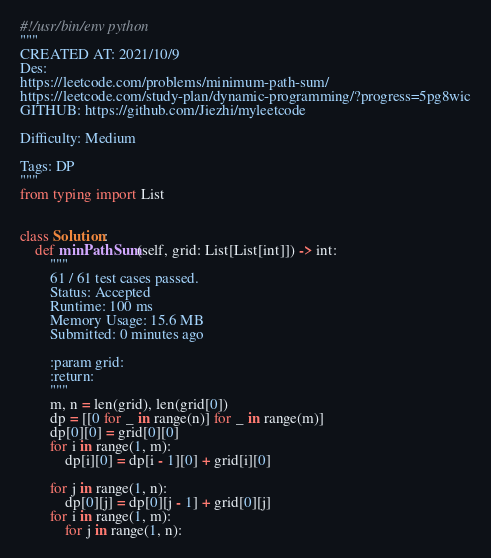<code> <loc_0><loc_0><loc_500><loc_500><_Python_>#!/usr/bin/env python
"""
CREATED AT: 2021/10/9
Des:
https://leetcode.com/problems/minimum-path-sum/
https://leetcode.com/study-plan/dynamic-programming/?progress=5pg8wic
GITHUB: https://github.com/Jiezhi/myleetcode

Difficulty: Medium

Tags: DP
"""
from typing import List


class Solution:
    def minPathSum(self, grid: List[List[int]]) -> int:
        """
        61 / 61 test cases passed.
        Status: Accepted
        Runtime: 100 ms
        Memory Usage: 15.6 MB
        Submitted: 0 minutes ago

        :param grid:
        :return:
        """
        m, n = len(grid), len(grid[0])
        dp = [[0 for _ in range(n)] for _ in range(m)]
        dp[0][0] = grid[0][0]
        for i in range(1, m):
            dp[i][0] = dp[i - 1][0] + grid[i][0]

        for j in range(1, n):
            dp[0][j] = dp[0][j - 1] + grid[0][j]
        for i in range(1, m):
            for j in range(1, n):</code> 